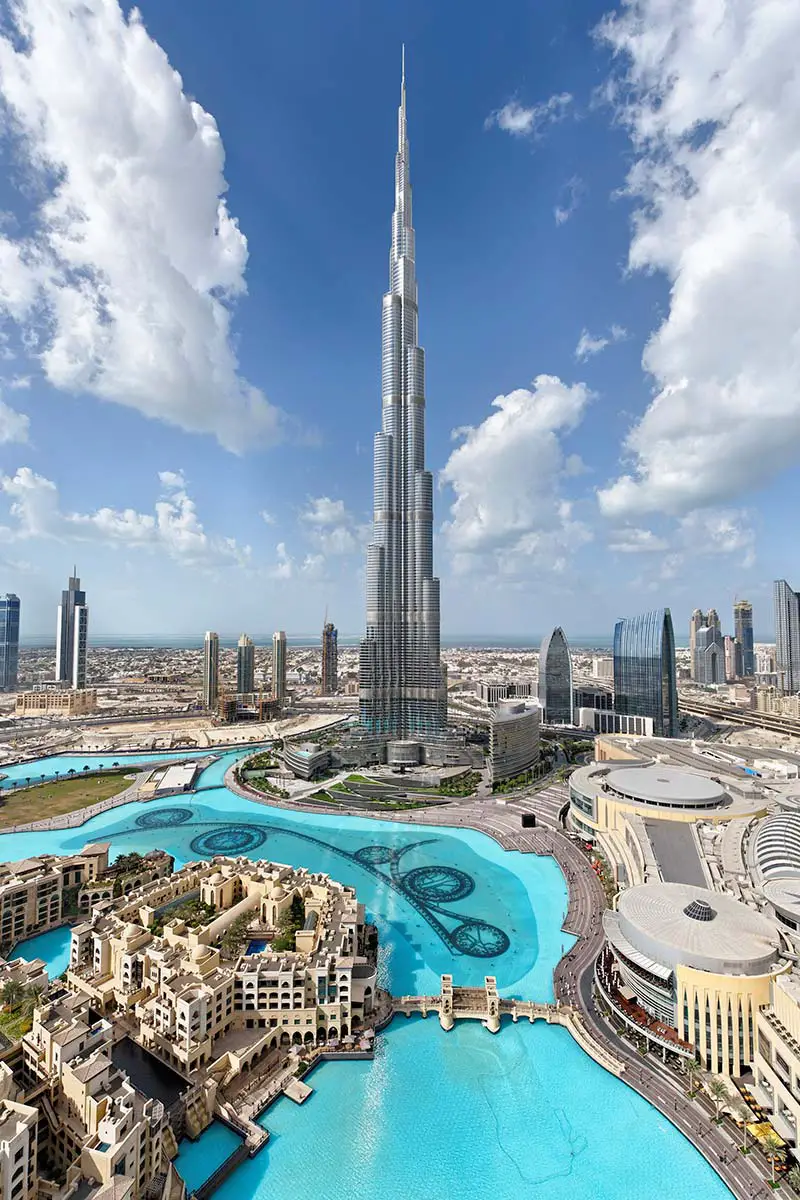What are the key elements in this picture?
 The image captures the majestic Burj Khalifa, the world's tallest building, piercing the sky in Dubai, United Arab Emirates. The photograph is taken from a high vantage point, providing a panoramic view of the cityscape. The Burj Khalifa stands as a towering silver spire, its many tiers culminating in a sharp pinnacle. The surrounding city is a blend of modern skyscrapers and intricate road networks, interspersed with a large expanse of blue-green water that adds a touch of nature to the urban landscape. Above, the sky is a clear blue, dotted with fluffy white clouds, creating a serene backdrop to the bustling city below. 